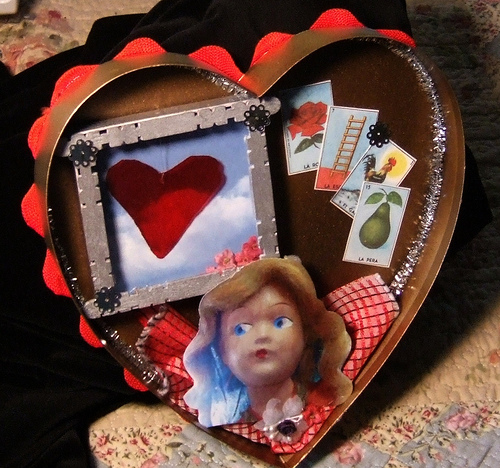<image>
Is the heart above the head? Yes. The heart is positioned above the head in the vertical space, higher up in the scene. 